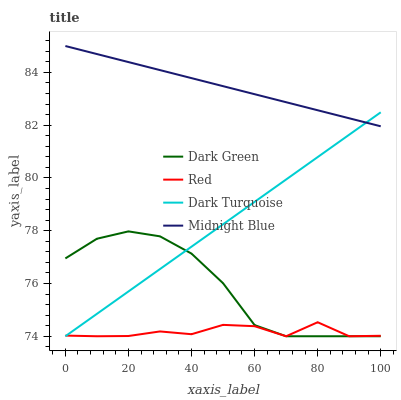Does Red have the minimum area under the curve?
Answer yes or no. Yes. Does Midnight Blue have the maximum area under the curve?
Answer yes or no. Yes. Does Midnight Blue have the minimum area under the curve?
Answer yes or no. No. Does Red have the maximum area under the curve?
Answer yes or no. No. Is Midnight Blue the smoothest?
Answer yes or no. Yes. Is Red the roughest?
Answer yes or no. Yes. Is Red the smoothest?
Answer yes or no. No. Is Midnight Blue the roughest?
Answer yes or no. No. Does Midnight Blue have the lowest value?
Answer yes or no. No. Does Red have the highest value?
Answer yes or no. No. Is Red less than Midnight Blue?
Answer yes or no. Yes. Is Midnight Blue greater than Red?
Answer yes or no. Yes. Does Red intersect Midnight Blue?
Answer yes or no. No. 